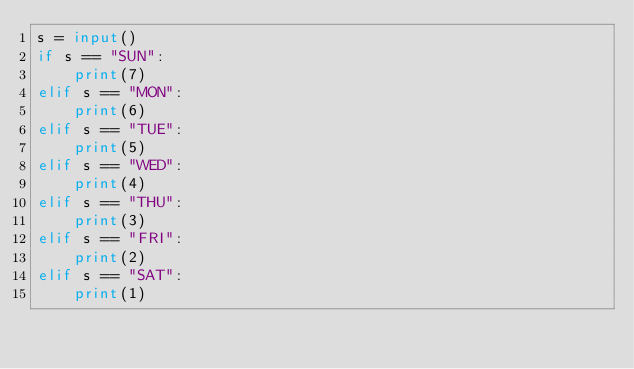Convert code to text. <code><loc_0><loc_0><loc_500><loc_500><_Python_>s = input()
if s == "SUN":
    print(7)
elif s == "MON":
    print(6)
elif s == "TUE":
    print(5)
elif s == "WED":
    print(4)
elif s == "THU":
    print(3)
elif s == "FRI":
    print(2)
elif s == "SAT":
    print(1)</code> 